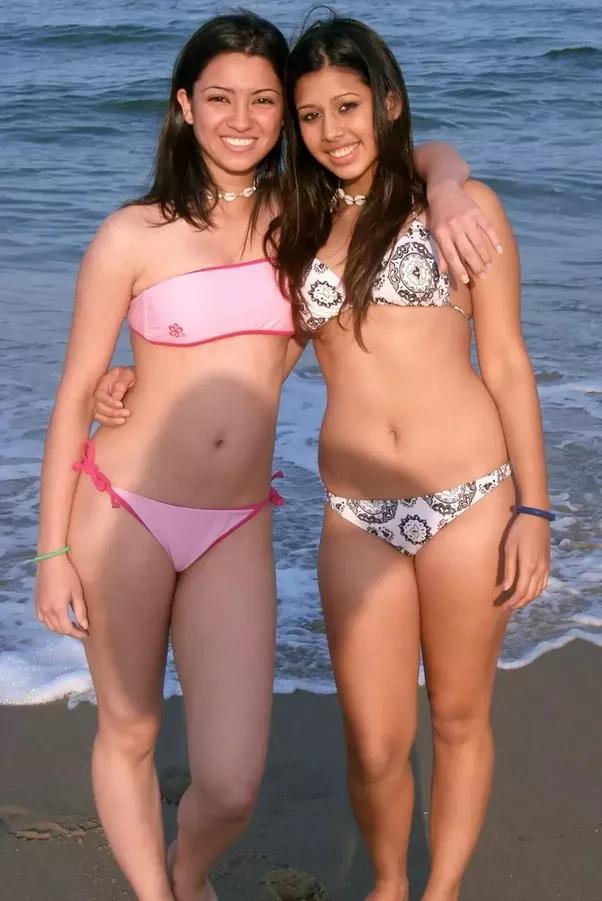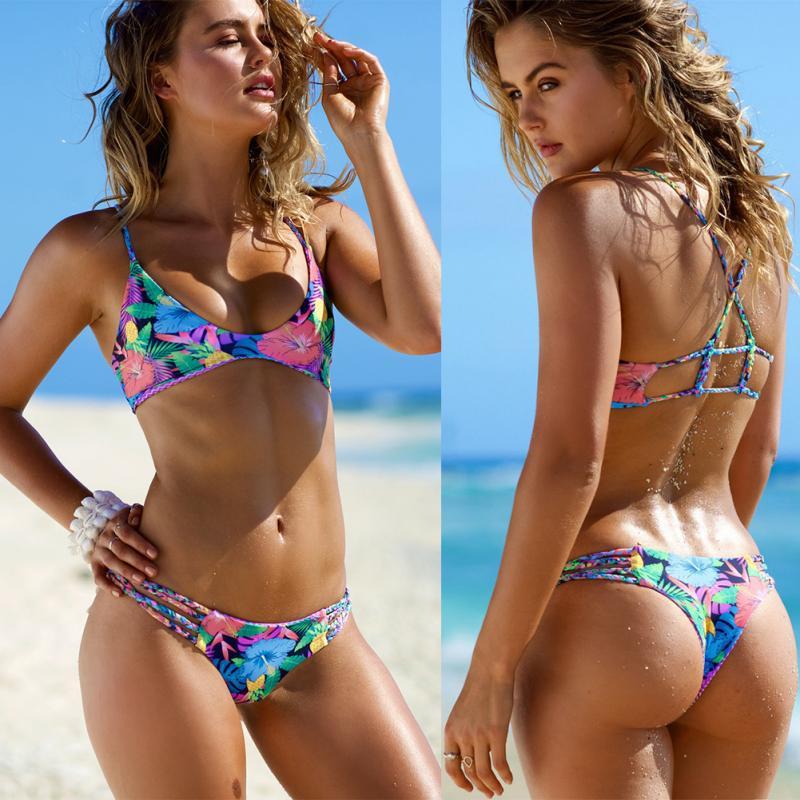The first image is the image on the left, the second image is the image on the right. Assess this claim about the two images: "There are three girls posing together in bikinis in the right image.". Correct or not? Answer yes or no. No. The first image is the image on the left, the second image is the image on the right. Analyze the images presented: Is the assertion "The right image has three women standing outside." valid? Answer yes or no. No. 